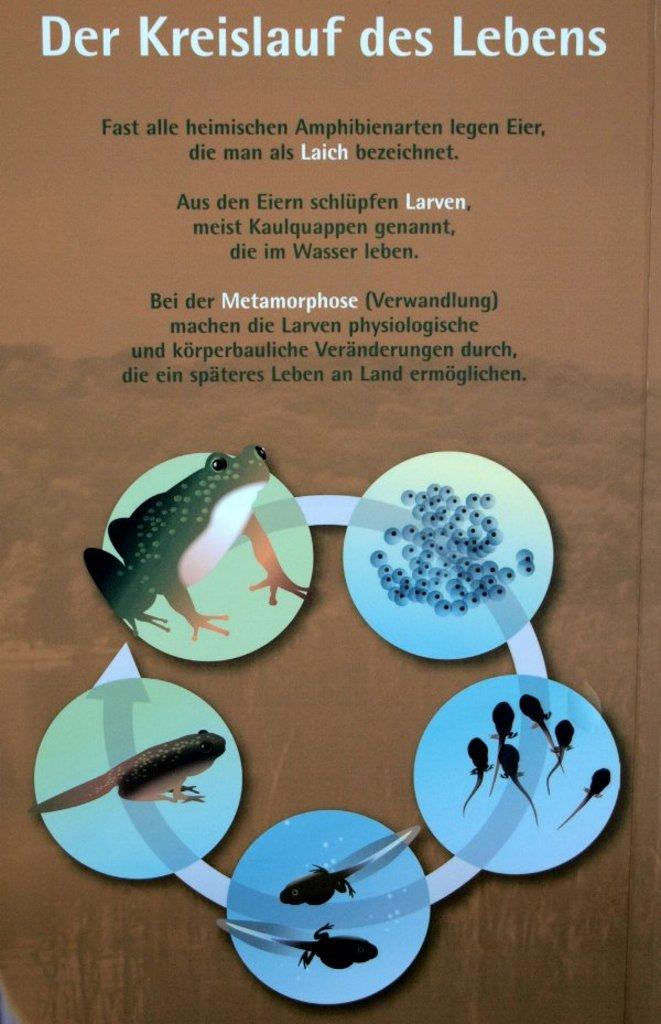What is the main subject of the image? The main subject of the image is the life cycle of a frog. Can you describe any additional features of the image? Yes, text is present at the top of the image. What type of bomb is shown in the image? There is no bomb present in the image; it depicts the life cycle of a frog. What kind of apparel is worn by the frog in the image? There is no frog wearing apparel in the image; it shows the different stages of a frog's life cycle. 